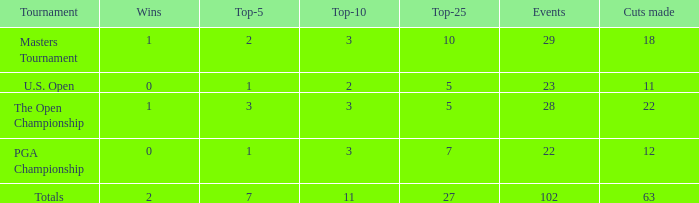How many top 10s connected with 3 top 5s and below 22 cuts made? None. 